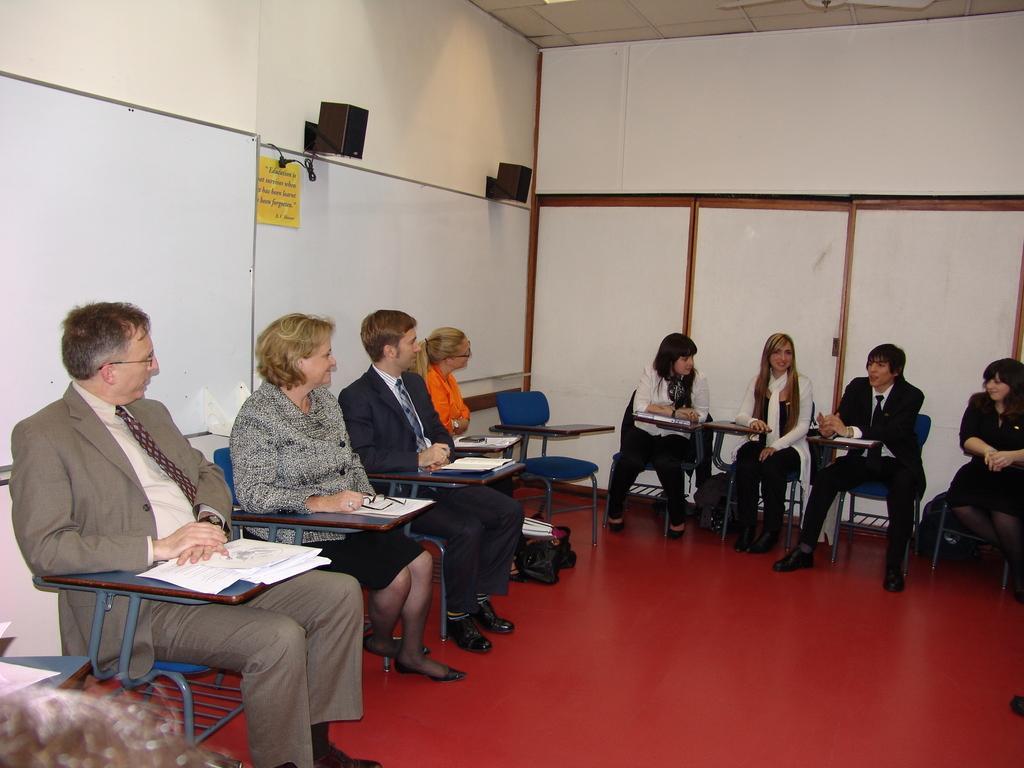Could you give a brief overview of what you see in this image? In this image I can see people sitting on chairs. There are paper, bags and walls. 